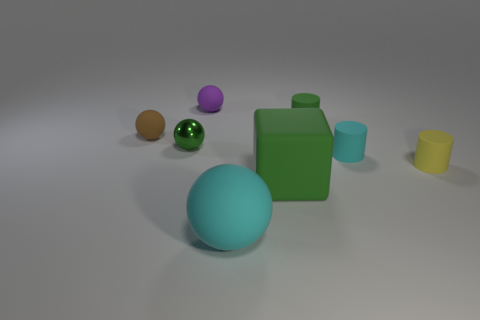There is a small green object to the left of the small green rubber cylinder; is it the same shape as the large green thing?
Keep it short and to the point. No. There is a cyan thing that is behind the large green thing; what is it made of?
Your answer should be compact. Rubber. What shape is the green matte thing that is in front of the cylinder behind the green metal sphere?
Ensure brevity in your answer.  Cube. Does the brown matte thing have the same shape as the tiny green thing in front of the tiny brown matte thing?
Give a very brief answer. Yes. What number of big cyan rubber balls are right of the small cylinder that is to the right of the cyan rubber cylinder?
Ensure brevity in your answer.  0. There is a tiny brown object that is the same shape as the small green metal object; what material is it?
Offer a terse response. Rubber. How many gray objects are either rubber balls or tiny matte balls?
Your answer should be very brief. 0. Is there anything else of the same color as the large block?
Make the answer very short. Yes. There is a small cylinder behind the cyan thing that is to the right of the tiny green matte thing; what is its color?
Make the answer very short. Green. Is the number of tiny rubber objects that are behind the purple rubber sphere less than the number of rubber objects behind the small green ball?
Ensure brevity in your answer.  Yes. 